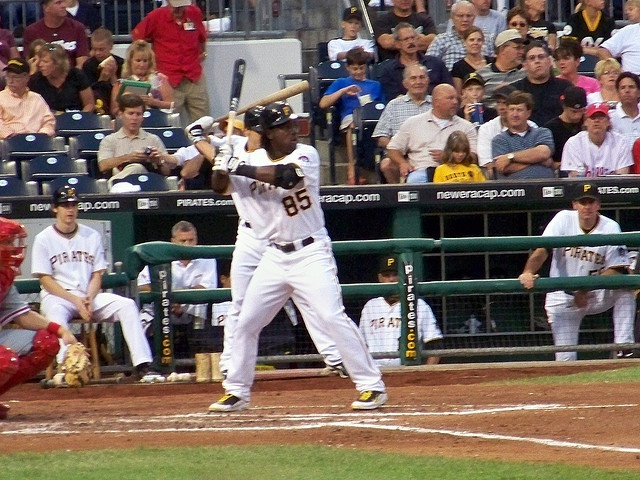Describe the objects in this image and their specific colors. I can see people in gray, black, brown, lightgray, and maroon tones, people in gray, lightgray, darkgray, and black tones, people in gray, lavender, darkgray, black, and tan tones, people in gray, lavender, darkgray, and black tones, and people in gray, darkgray, and black tones in this image. 